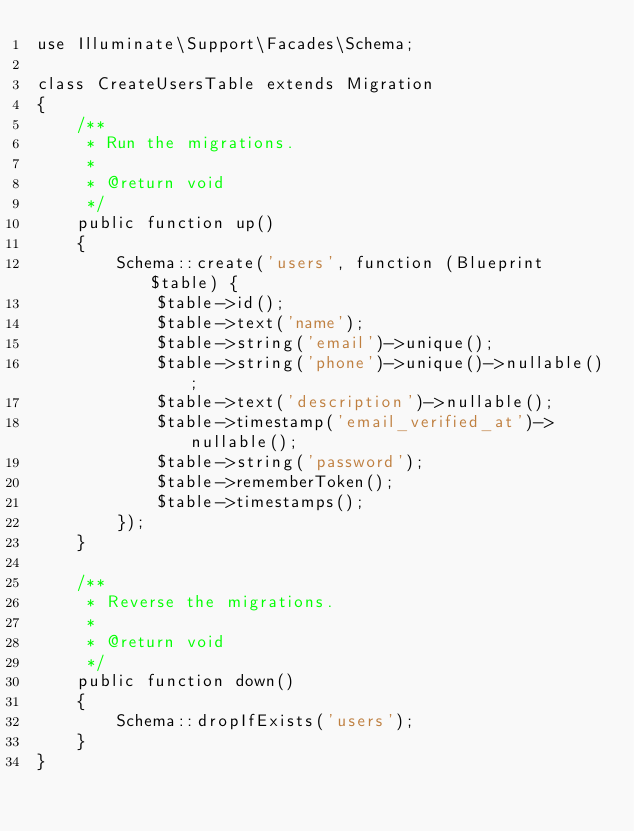<code> <loc_0><loc_0><loc_500><loc_500><_PHP_>use Illuminate\Support\Facades\Schema;

class CreateUsersTable extends Migration
{
    /**
     * Run the migrations.
     *
     * @return void
     */
    public function up()
    {
        Schema::create('users', function (Blueprint $table) {
            $table->id();
            $table->text('name');
            $table->string('email')->unique();
            $table->string('phone')->unique()->nullable();
            $table->text('description')->nullable();
            $table->timestamp('email_verified_at')->nullable();
            $table->string('password');
            $table->rememberToken();
            $table->timestamps();
        });
    }

    /**
     * Reverse the migrations.
     *
     * @return void
     */
    public function down()
    {
        Schema::dropIfExists('users');
    }
}
</code> 